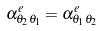<formula> <loc_0><loc_0><loc_500><loc_500>\alpha _ { \theta _ { 2 } \theta _ { 1 } } ^ { e } = \alpha _ { \theta _ { 1 } \theta _ { 2 } } ^ { e }</formula> 